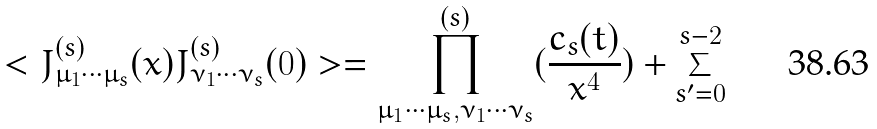<formula> <loc_0><loc_0><loc_500><loc_500>< J _ { \mu _ { 1 } \cdots \mu _ { s } } ^ { ( s ) } ( x ) J _ { \nu _ { 1 } \cdots \nu _ { s } } ^ { ( s ) } ( 0 ) > = \prod _ { \mu _ { 1 } \cdots \mu _ { s } , \nu _ { 1 } \cdots \nu _ { s } } ^ { ( s ) } ( \frac { c _ { s } ( t ) } { x ^ { 4 } } ) + \sum _ { s ^ { \prime } = 0 } ^ { s - 2 }</formula> 